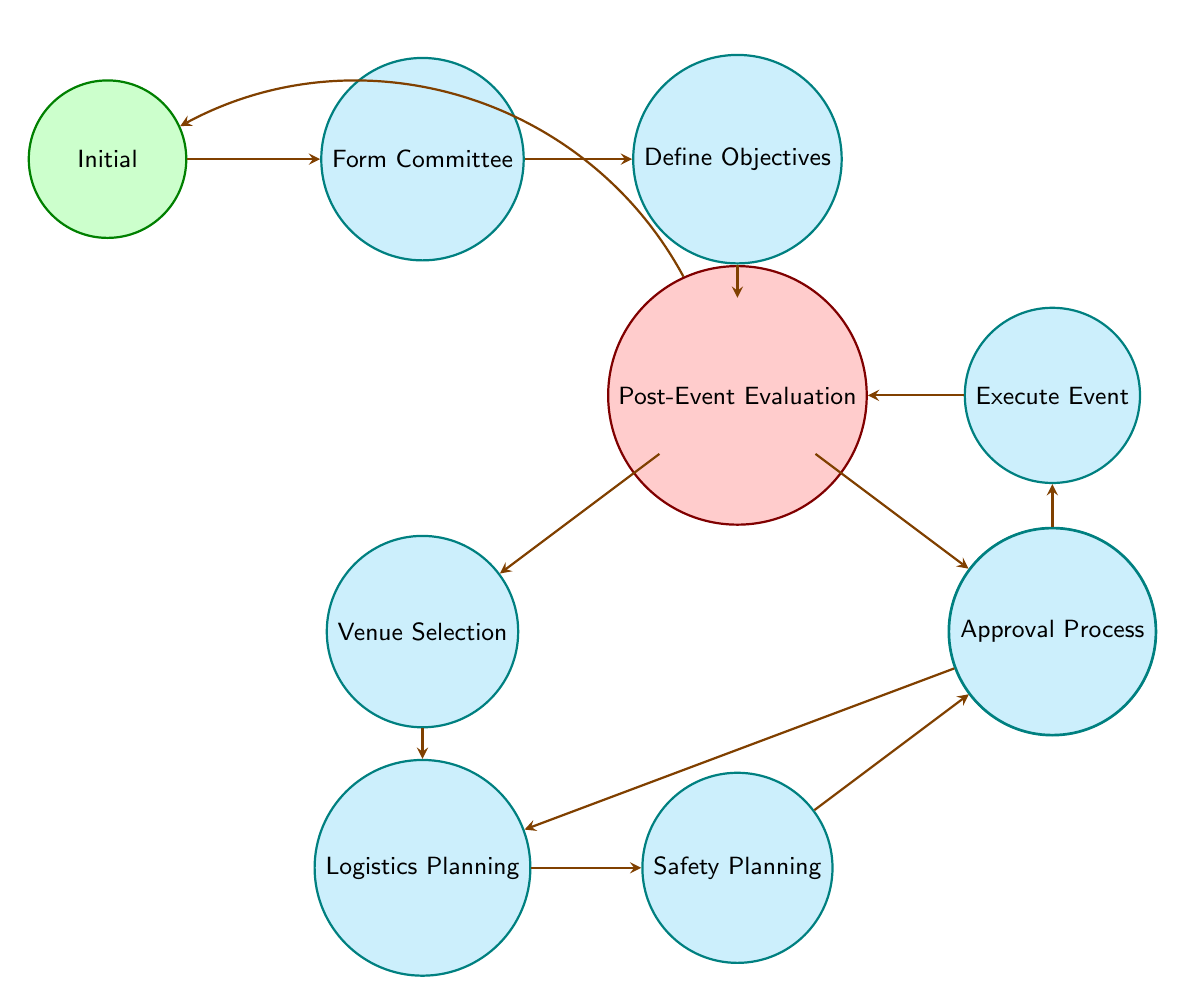What is the first state in the event planning process? The diagram shows the initial state labeled 'Initial', indicating the start of the event planning process.
Answer: Initial How many total states are there in the diagram? By counting the nodes in the diagram, we can identify a total of eleven distinct states regarding the event planning process.
Answer: 11 Which state follows 'Develop Budget'? According to the diagram, the state that follows 'Develop Budget' can be either 'Venue Selection' or 'Vendor Contracts' as both are connected to 'Develop Budget'.
Answer: Venue Selection, Vendor Contracts What is the last state before the event is executed? The node that directly precedes 'Execute Event' is 'Approval Process', showing that this is the last step before implementing the event.
Answer: Approval Process What do 'Vendor Contracts' and 'Venue Selection' have in common? Both 'Vendor Contracts' and 'Venue Selection' are transition states that lead to 'Logistics Planning', linking them in the event planning process.
Answer: Logistics Planning Which state requires a comprehensive safety plan? The state that specifically involves developing a safety plan is labeled 'Safety Planning' as indicated in the flow of the diagram.
Answer: Safety Planning How does one transition from 'Post-Event Evaluation'? The diagram shows that after completing 'Post-Event Evaluation', the process will loop back to 'Initial', indicating a continuous cycle in event planning.
Answer: Initial In what state is the budget developed? The diagram specifies that the state for creating a budget is 'Develop Budget', showing its key role in the planning process.
Answer: Develop Budget What is the overall last action in the finite state machine? The final action in the process is represented by the state 'Execute Event', indicating the implementation of the event.
Answer: Execute Event 